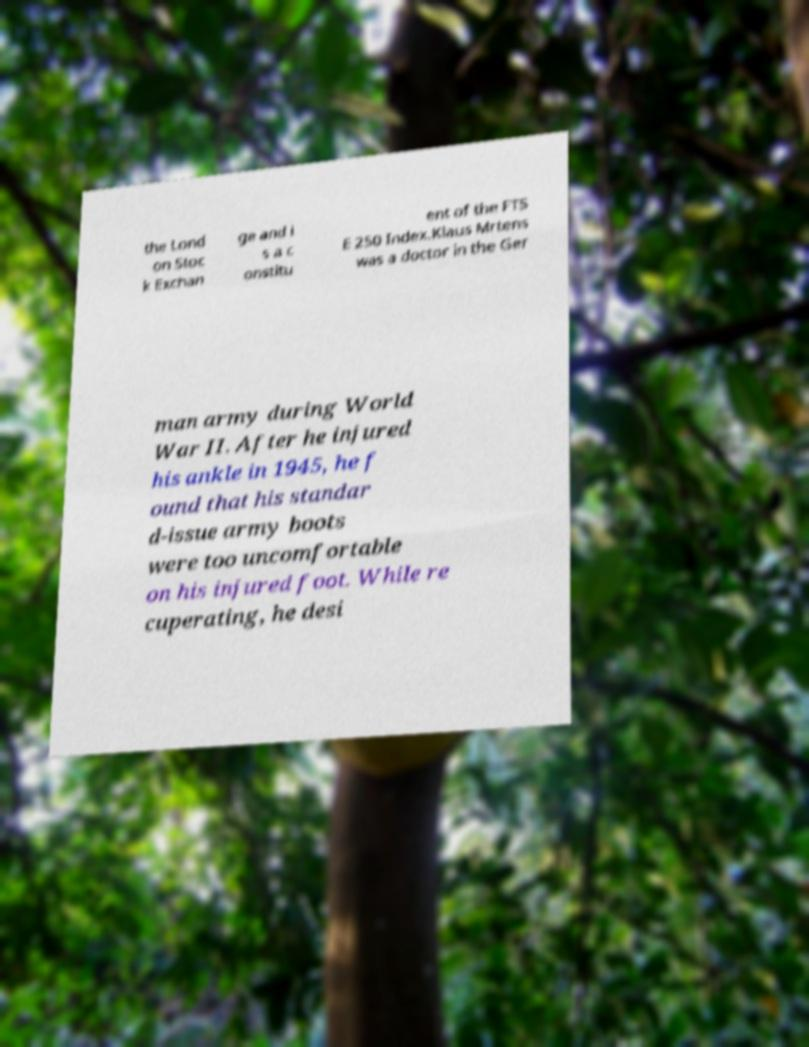Can you accurately transcribe the text from the provided image for me? the Lond on Stoc k Exchan ge and i s a c onstitu ent of the FTS E 250 Index.Klaus Mrtens was a doctor in the Ger man army during World War II. After he injured his ankle in 1945, he f ound that his standar d-issue army boots were too uncomfortable on his injured foot. While re cuperating, he desi 